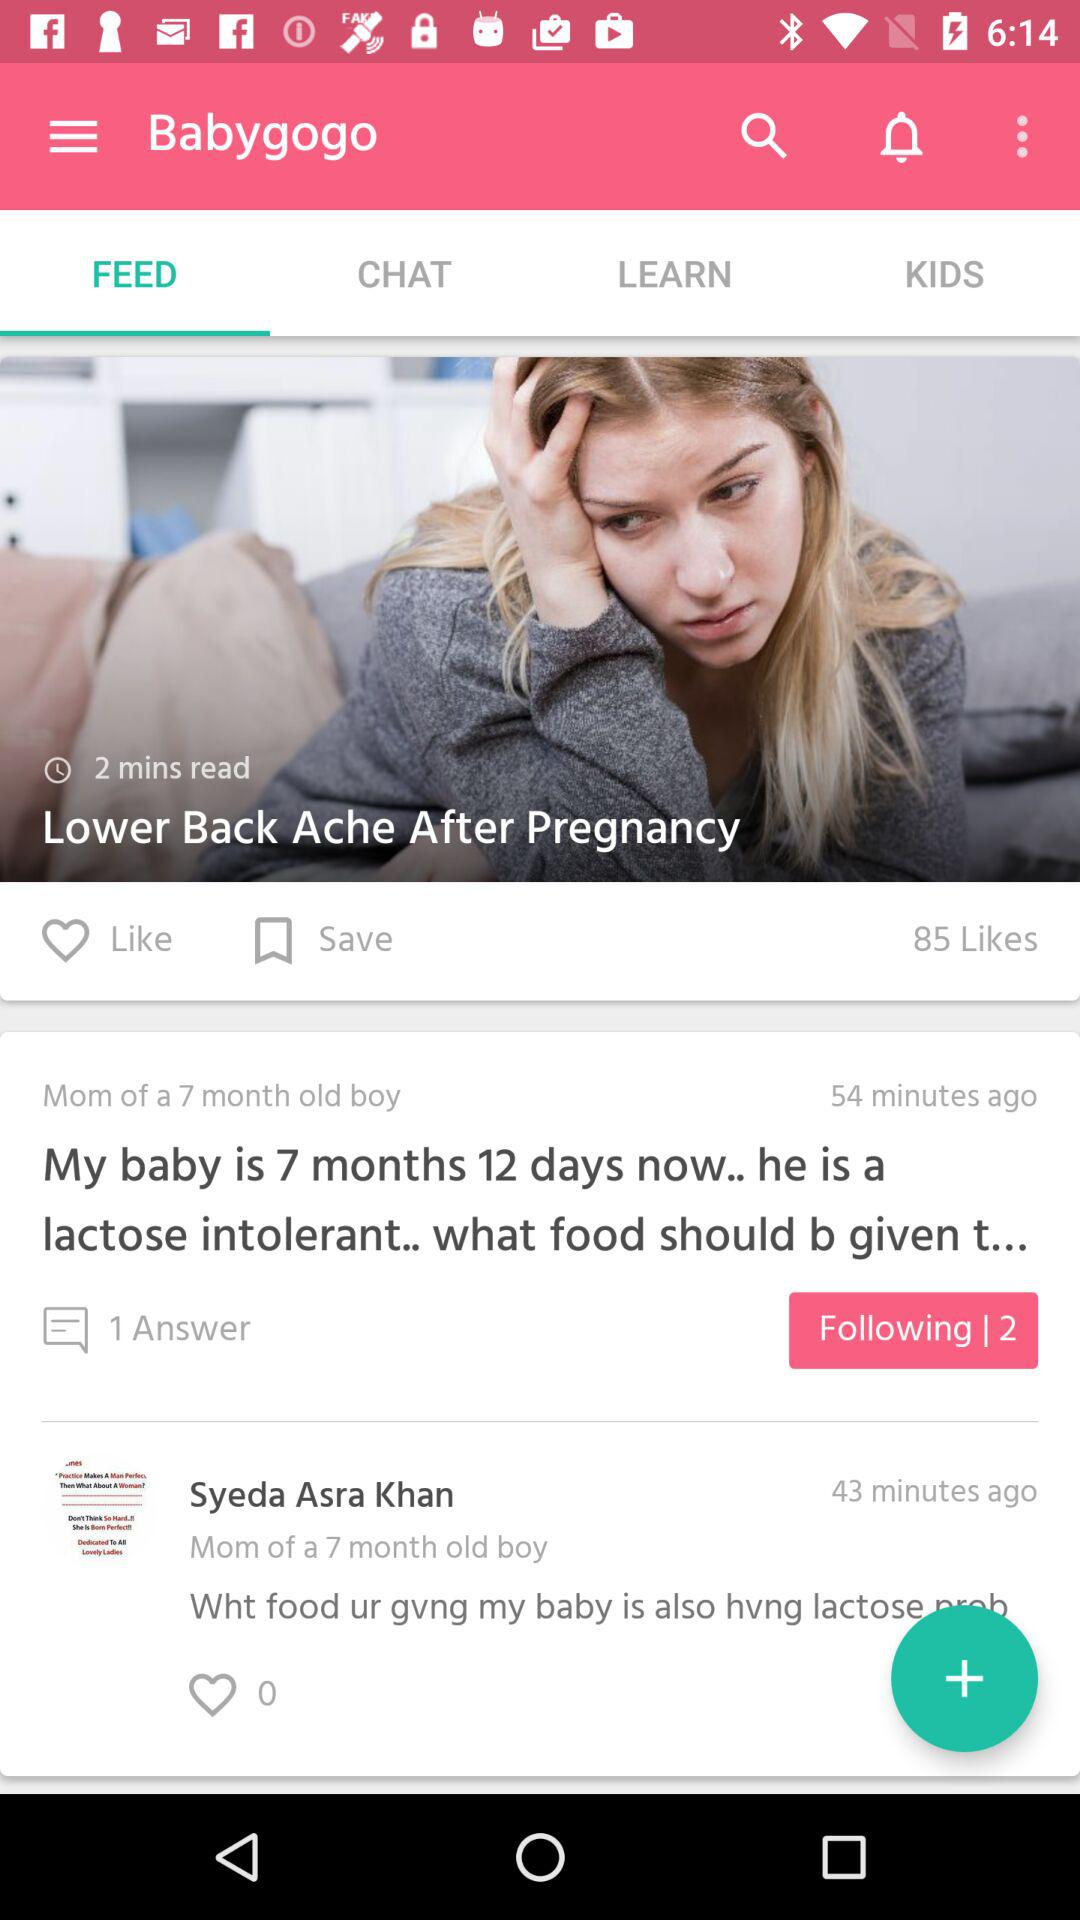How many likes does the post have?
Answer the question using a single word or phrase. 85 